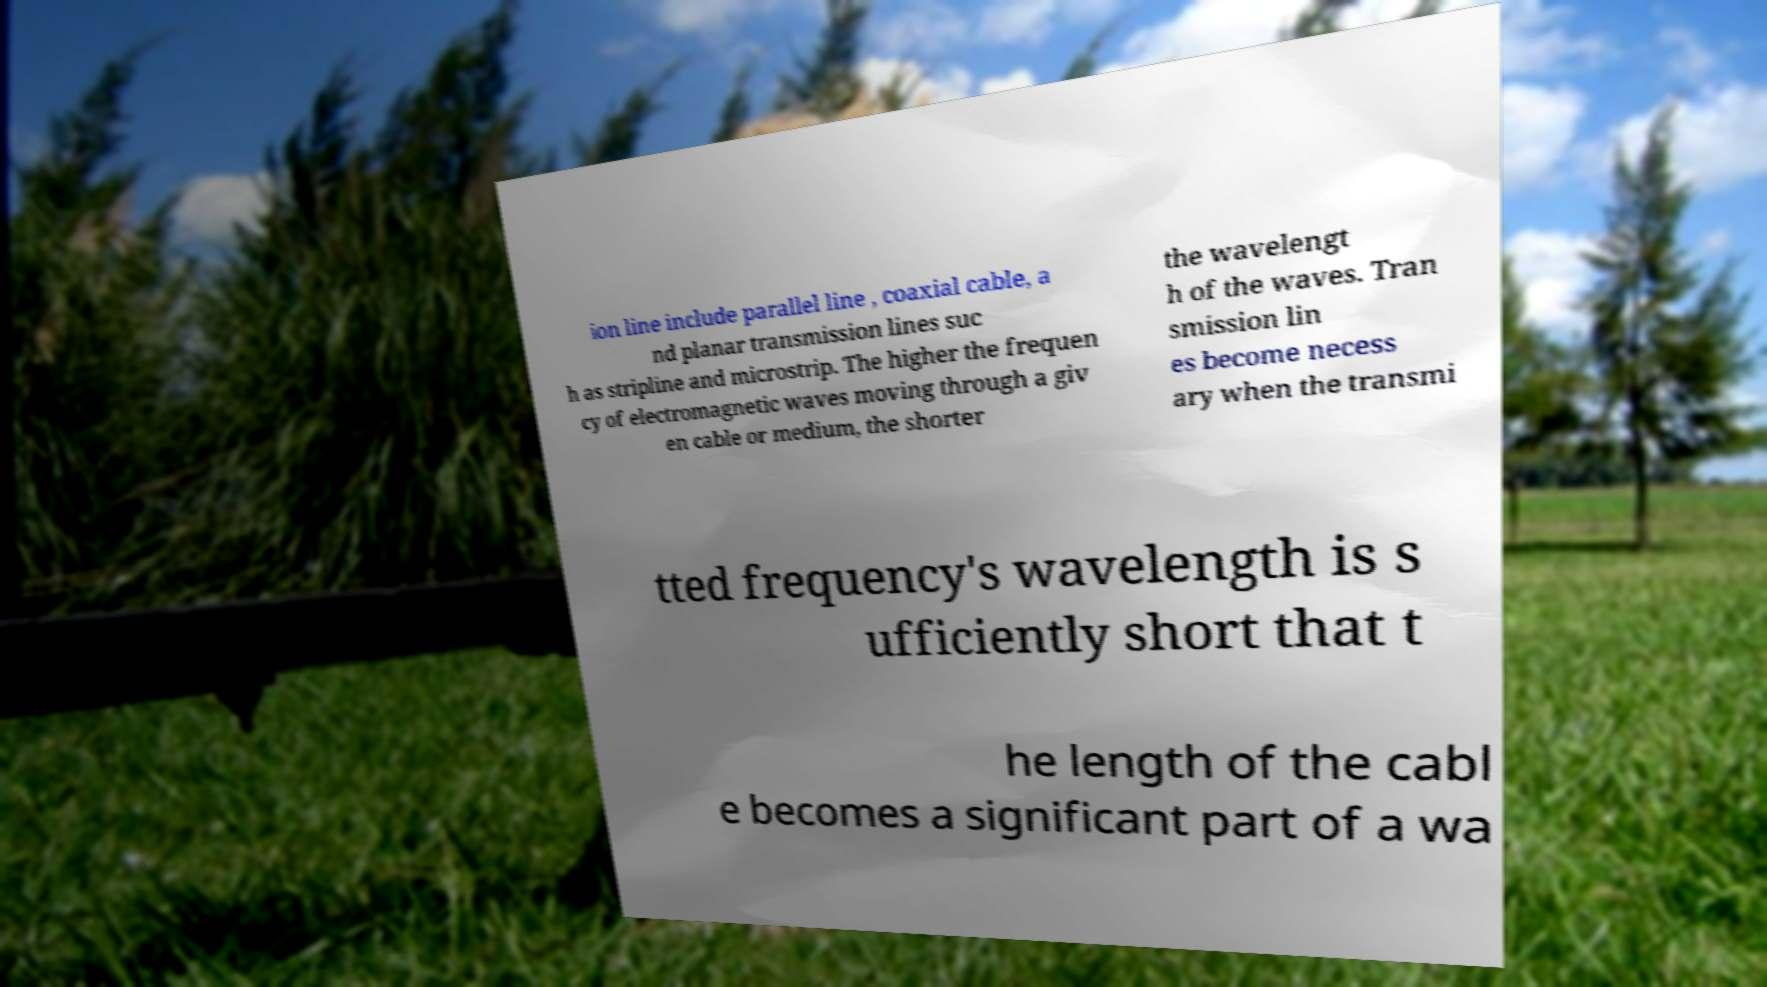Could you assist in decoding the text presented in this image and type it out clearly? ion line include parallel line , coaxial cable, a nd planar transmission lines suc h as stripline and microstrip. The higher the frequen cy of electromagnetic waves moving through a giv en cable or medium, the shorter the wavelengt h of the waves. Tran smission lin es become necess ary when the transmi tted frequency's wavelength is s ufficiently short that t he length of the cabl e becomes a significant part of a wa 